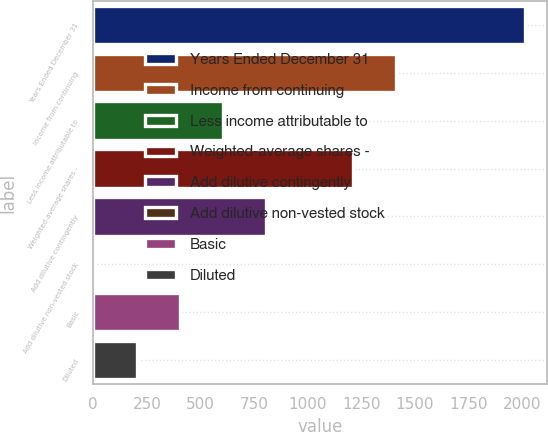<chart> <loc_0><loc_0><loc_500><loc_500><bar_chart><fcel>Years Ended December 31<fcel>Income from continuing<fcel>Less income attributable to<fcel>Weighted-average shares -<fcel>Add dilutive contingently<fcel>Add dilutive non-vested stock<fcel>Basic<fcel>Diluted<nl><fcel>2014<fcel>1410.07<fcel>604.83<fcel>1208.76<fcel>806.14<fcel>0.9<fcel>403.52<fcel>202.21<nl></chart> 